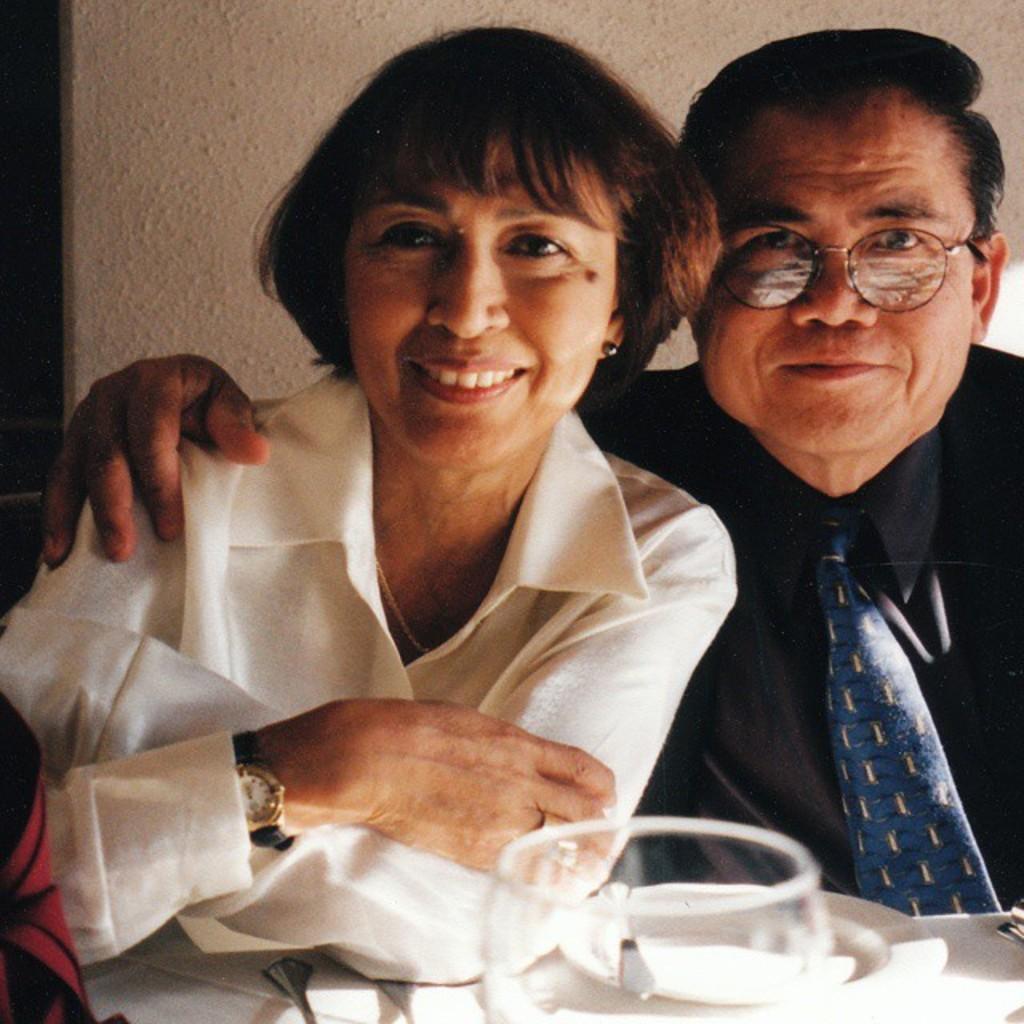How would you summarize this image in a sentence or two? In this image there is a woman and a man are behind a table having a glass, plate, napkin, spoon on it. Plate is having spoon on it. Person is wearing a black shirt and tie. Woman is wearing a white shirt and watch. Behind them there is wall. 